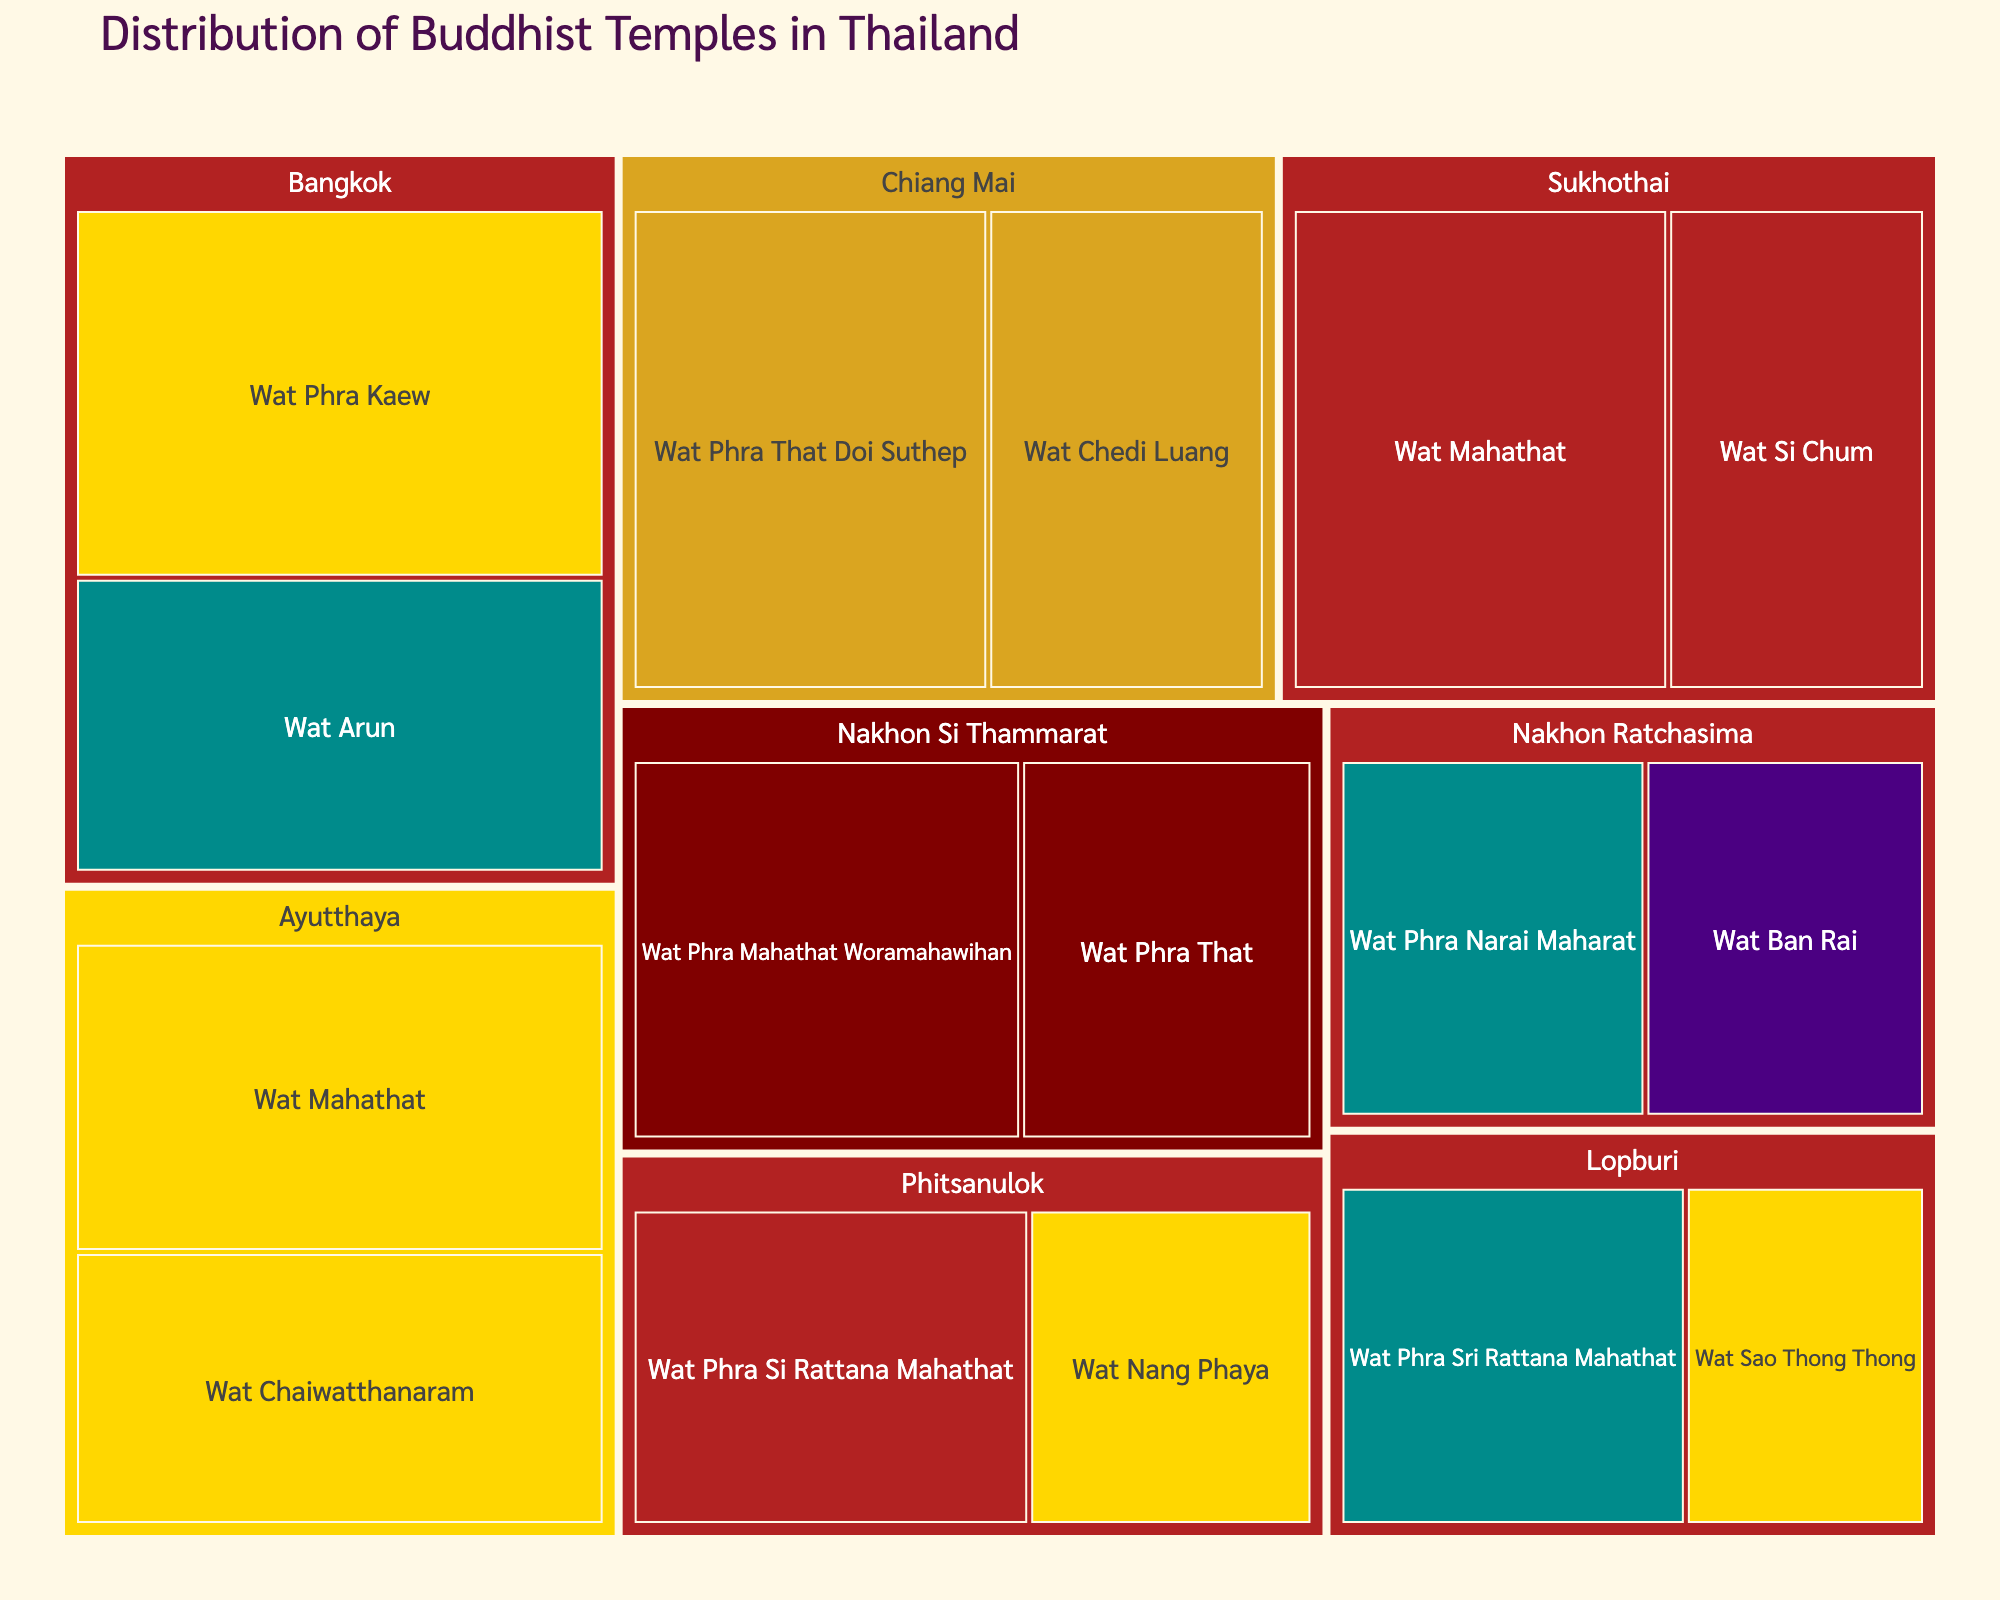What is the title of the treemap? The title is at the top of the treemap and usually provides an overview of the content. In this case, it should be clearly indicated.
Answer: Distribution of Buddhist Temples in Thailand Which province has the largest temple by size, and what is the name of the temple? By observing the blocks in the treemap, the largest block representing the temple will indicate the largest temple by size within its province.
Answer: Bangkok, Wat Phra Kaew How many Buddhist temples in Chiang Mai are included in the treemap? Look for the group labeled "Chiang Mai" and count the number of sub-blocks within it, each representing a temple.
Answer: 2 Which architectural style is common in Sukhothai province and how many temples share this style? Find the Sukhothai group and observe the color-coding for architectural styles. Count the number of sub-blocks with the same color/style.
Answer: Sukhothai, 2 Compare the sizes of Wat Arun in Bangkok and Wat Mahathat in Ayutthaya. Which one is larger? Identify the blocks representing Wat Arun and Wat Mahathat, then compare their sizes, which is indicated by the area of each block.
Answer: Wat Phra Kaew is larger What is the total number of temples included in the treemap? Count all the sub-blocks within the treemap, each representing an individual temple.
Answer: 15 Which province has temples with the greatest diversity of architectural styles? Check each province group and count the number of different colors/styles. The one with the most different colors has the greatest diversity.
Answer: Ayutthaya In Nakhon Ratchasima, which architectural style is represented and by how many temples? Locate the Nakhon Ratchasima group and note down the colors representing architectural styles, then count the temples for each style.
Answer: Khmer-influenced, Contemporary; 1 temple for each style What is the smallest temple by size in Ayutthaya and what is its architectural style? Within the Ayutthaya group, find the smallest block and its associated color/label for architectural style.
Answer: Wat Sao Thong Thong, Ayutthaya Sukhothai and Nakhon Ratchasima both have a Wat Mahathat. Which one is larger? Identify the blocks for Wat Mahathat in both Sukhothai and Nakhon Ratchasima, then compare their sizes.
Answer: Wat Mahathat in Sukhothai is larger 